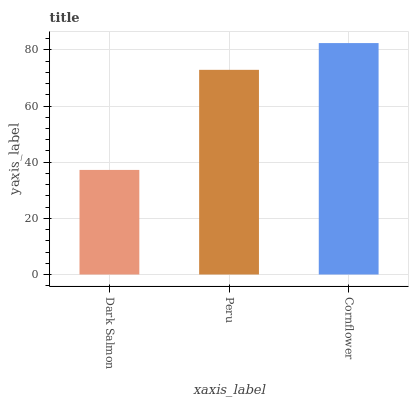Is Dark Salmon the minimum?
Answer yes or no. Yes. Is Cornflower the maximum?
Answer yes or no. Yes. Is Peru the minimum?
Answer yes or no. No. Is Peru the maximum?
Answer yes or no. No. Is Peru greater than Dark Salmon?
Answer yes or no. Yes. Is Dark Salmon less than Peru?
Answer yes or no. Yes. Is Dark Salmon greater than Peru?
Answer yes or no. No. Is Peru less than Dark Salmon?
Answer yes or no. No. Is Peru the high median?
Answer yes or no. Yes. Is Peru the low median?
Answer yes or no. Yes. Is Dark Salmon the high median?
Answer yes or no. No. Is Cornflower the low median?
Answer yes or no. No. 